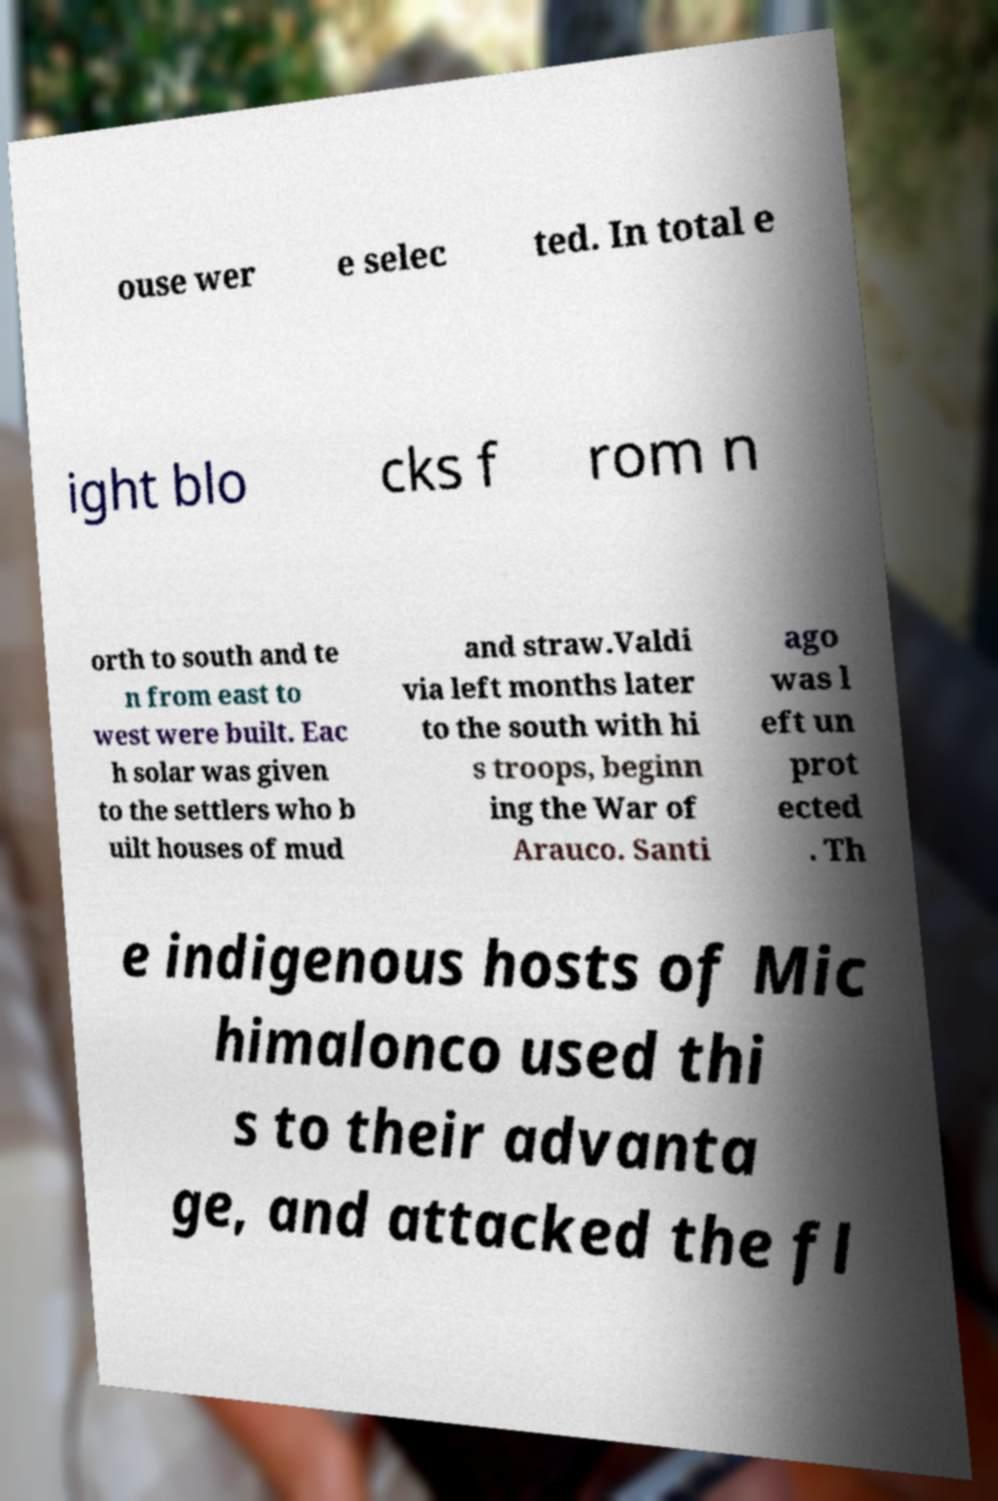Please read and relay the text visible in this image. What does it say? ouse wer e selec ted. In total e ight blo cks f rom n orth to south and te n from east to west were built. Eac h solar was given to the settlers who b uilt houses of mud and straw.Valdi via left months later to the south with hi s troops, beginn ing the War of Arauco. Santi ago was l eft un prot ected . Th e indigenous hosts of Mic himalonco used thi s to their advanta ge, and attacked the fl 